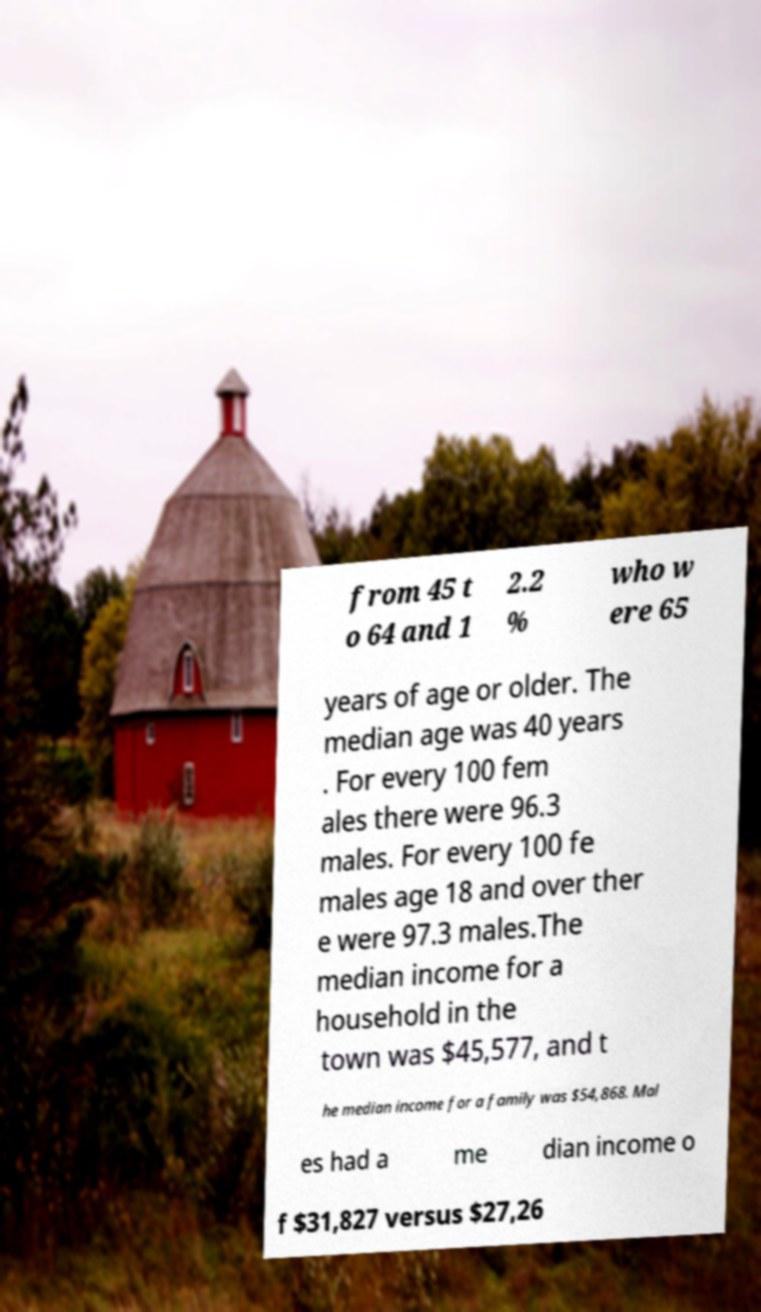Please read and relay the text visible in this image. What does it say? from 45 t o 64 and 1 2.2 % who w ere 65 years of age or older. The median age was 40 years . For every 100 fem ales there were 96.3 males. For every 100 fe males age 18 and over ther e were 97.3 males.The median income for a household in the town was $45,577, and t he median income for a family was $54,868. Mal es had a me dian income o f $31,827 versus $27,26 